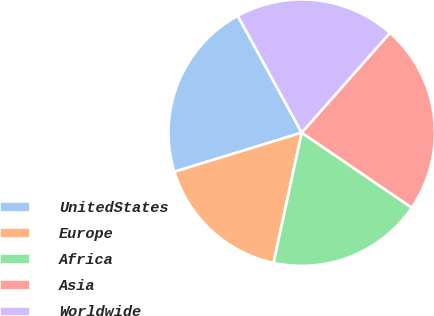<chart> <loc_0><loc_0><loc_500><loc_500><pie_chart><fcel>UnitedStates<fcel>Europe<fcel>Africa<fcel>Asia<fcel>Worldwide<nl><fcel>21.78%<fcel>16.87%<fcel>18.87%<fcel>23.0%<fcel>19.49%<nl></chart> 